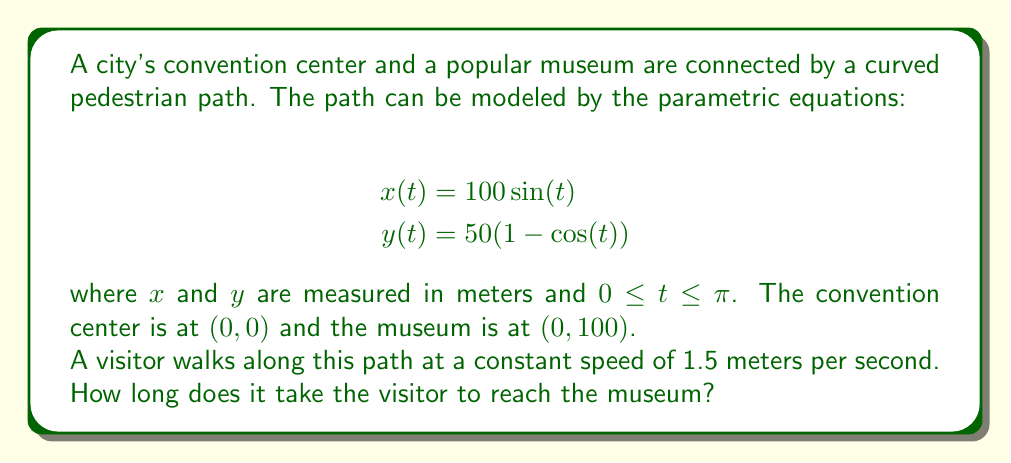Show me your answer to this math problem. To solve this problem, we need to follow these steps:

1) First, we need to find the length of the path. The length of a parametric curve is given by the formula:

   $$L = \int_a^b \sqrt{\left(\frac{dx}{dt}\right)^2 + \left(\frac{dy}{dt}\right)^2} dt$$

2) We need to find $\frac{dx}{dt}$ and $\frac{dy}{dt}$:

   $$\frac{dx}{dt} = 100\cos(t)$$
   $$\frac{dy}{dt} = 50\sin(t)$$

3) Substituting these into the length formula:

   $$L = \int_0^\pi \sqrt{(100\cos(t))^2 + (50\sin(t))^2} dt$$

4) Simplifying under the square root:

   $$L = \int_0^\pi \sqrt{10000\cos^2(t) + 2500\sin^2(t)} dt$$
   $$L = 100\int_0^\pi \sqrt{\cos^2(t) + \frac{1}{4}\sin^2(t)} dt$$

5) This integral doesn't have an elementary antiderivative. We need to evaluate it numerically. Using a calculator or computer software, we find:

   $$L \approx 157.08 \text{ meters}$$

6) Now that we know the length of the path, we can calculate the time taken to walk it at a constant speed of 1.5 m/s:

   $$\text{Time} = \frac{\text{Distance}}{\text{Speed}} = \frac{157.08}{1.5} \approx 104.72 \text{ seconds}$$
Answer: It takes approximately 104.72 seconds (or about 1 minute and 45 seconds) for the visitor to reach the museum. 